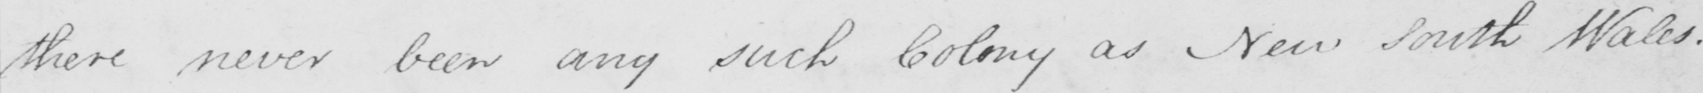Please provide the text content of this handwritten line. there never been any such Colony as New South Wales . 